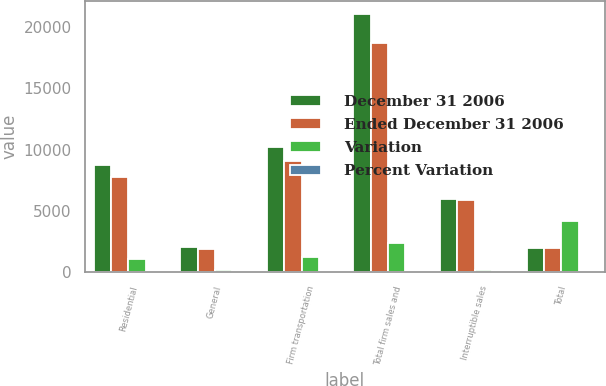Convert chart. <chart><loc_0><loc_0><loc_500><loc_500><stacked_bar_chart><ecel><fcel>Residential<fcel>General<fcel>Firm transportation<fcel>Total firm sales and<fcel>Interruptible sales<fcel>Total<nl><fcel>December 31 2006<fcel>8768<fcel>2066<fcel>10248<fcel>21082<fcel>5983<fcel>1979<nl><fcel>Ended December 31 2006<fcel>7758<fcel>1892<fcel>9058<fcel>18708<fcel>5856<fcel>1979<nl><fcel>Variation<fcel>1010<fcel>174<fcel>1190<fcel>2374<fcel>127<fcel>4122<nl><fcel>Percent Variation<fcel>13<fcel>9.2<fcel>13.1<fcel>12.7<fcel>2.2<fcel>14.4<nl></chart> 